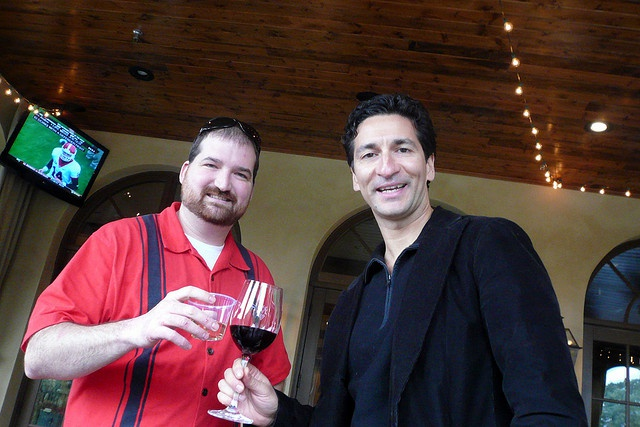Describe the objects in this image and their specific colors. I can see people in black, lightgray, darkgray, and navy tones, people in black, lavender, salmon, and brown tones, tv in black, green, teal, and lightblue tones, wine glass in black, white, brown, and violet tones, and cup in black, lavender, violet, and lightpink tones in this image. 